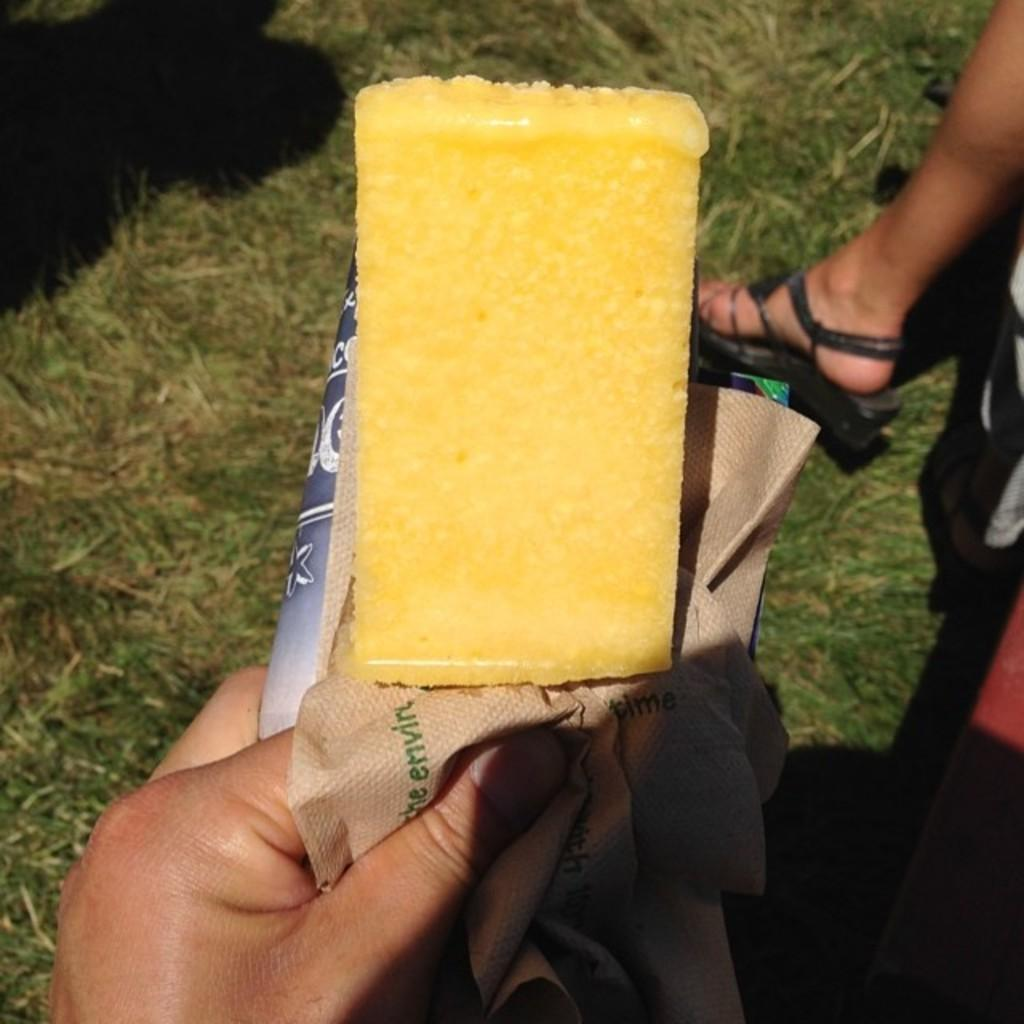What can be seen in the middle of the image? There is a person's hand in the middle of the image. What is the person doing with their hand? The person is holding objects. What else can be seen on the right side of the image? There is a human leg visible on the right side of the image. What type of environment is depicted in the image? Grass is present in the image, suggesting an outdoor setting. How many ladybugs can be seen on the person's hand in the image? There are no ladybugs present in the image. What type of transportation is available at the airport in the image? There is no airport present in the image. 